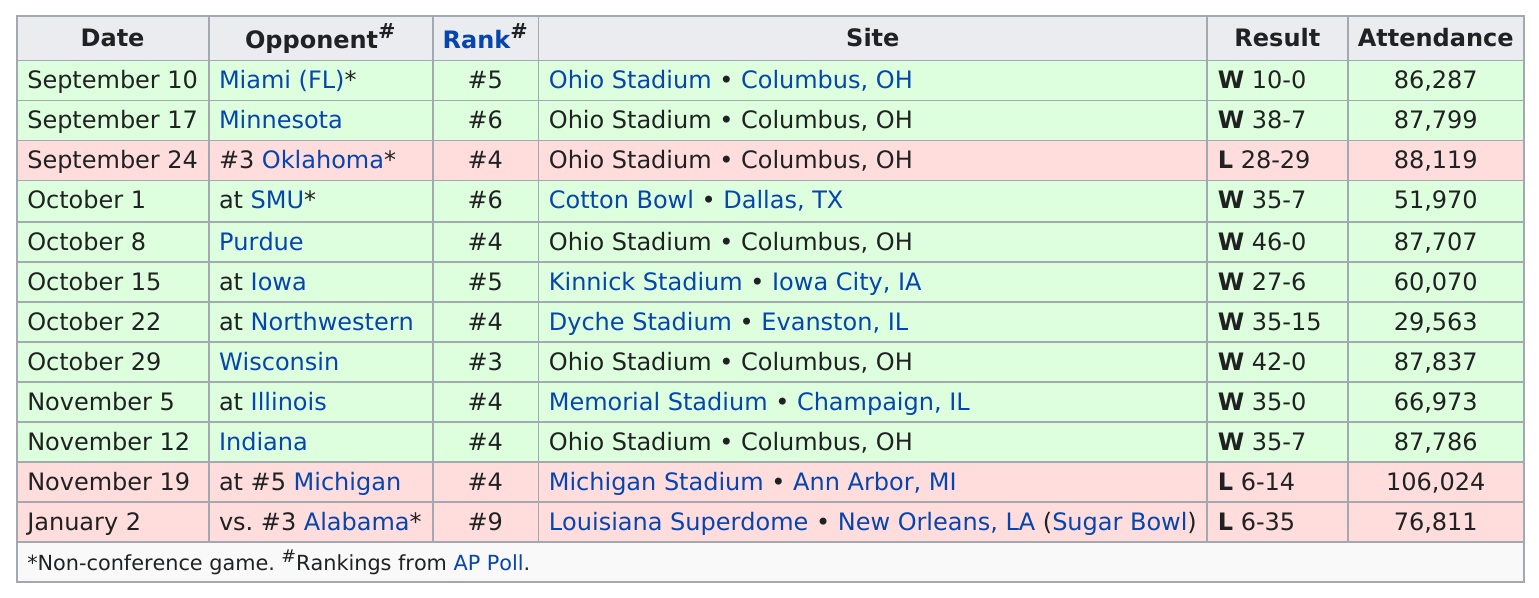Identify some key points in this picture. During this season, this team won a grand total of 9 games. This team has won by the least amount of points this season, a mere 10 points! The last game attended by fewer than 30,000 people was on October 22. I'm sorry, but I'm not sure what you are trying to ask. Could you please provide more context or clarify your question? The number of wins and the number of losses differ by 6. 